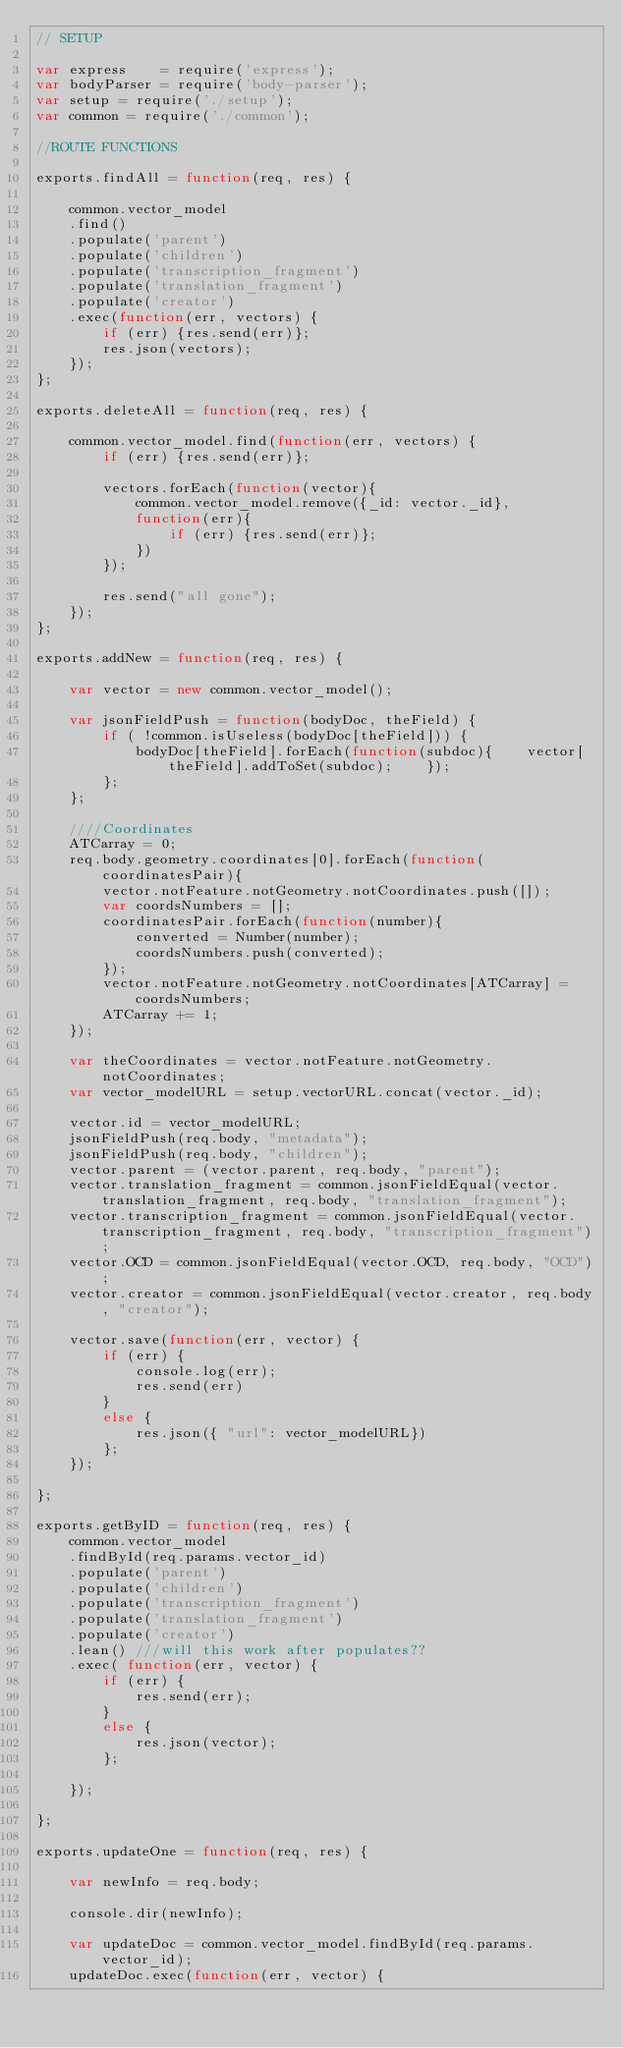Convert code to text. <code><loc_0><loc_0><loc_500><loc_500><_JavaScript_>// SETUP

var express    = require('express');
var bodyParser = require('body-parser');
var setup = require('./setup');
var common = require('./common');

//ROUTE FUNCTIONS

exports.findAll = function(req, res) {
      
    common.vector_model
    .find()
    .populate('parent')
    .populate('children')
    .populate('transcription_fragment')
    .populate('translation_fragment')
    .populate('creator')
    .exec(function(err, vectors) {
        if (err) {res.send(err)};
        res.json(vectors);
    }); 
};

exports.deleteAll = function(req, res) {
      
    common.vector_model.find(function(err, vectors) {
        if (err) {res.send(err)};

        vectors.forEach(function(vector){
            common.vector_model.remove({_id: vector._id},
            function(err){
                if (err) {res.send(err)};
            })
        });

        res.send("all gone");
    }); 
};

exports.addNew = function(req, res) {
    
    var vector = new common.vector_model(); 

    var jsonFieldPush = function(bodyDoc, theField) {
        if ( !common.isUseless(bodyDoc[theField])) {
            bodyDoc[theField].forEach(function(subdoc){    vector[theField].addToSet(subdoc);    });
        };
    };

    ////Coordinates
    ATCarray = 0;
    req.body.geometry.coordinates[0].forEach(function(coordinatesPair){
        vector.notFeature.notGeometry.notCoordinates.push([]);
        var coordsNumbers = [];
        coordinatesPair.forEach(function(number){
            converted = Number(number);
            coordsNumbers.push(converted);
        });
        vector.notFeature.notGeometry.notCoordinates[ATCarray] = coordsNumbers;
        ATCarray += 1;      
    });

    var theCoordinates = vector.notFeature.notGeometry.notCoordinates;
    var vector_modelURL = setup.vectorURL.concat(vector._id);

    vector.id = vector_modelURL;
    jsonFieldPush(req.body, "metadata");
    jsonFieldPush(req.body, "children");
    vector.parent = (vector.parent, req.body, "parent");
    vector.translation_fragment = common.jsonFieldEqual(vector.translation_fragment, req.body, "translation_fragment");
    vector.transcription_fragment = common.jsonFieldEqual(vector.transcription_fragment, req.body, "transcription_fragment");
    vector.OCD = common.jsonFieldEqual(vector.OCD, req.body, "OCD");
    vector.creator = common.jsonFieldEqual(vector.creator, req.body, "creator");

    vector.save(function(err, vector) {
        if (err) {
            console.log(err);
            res.send(err)
        }
        else {
            res.json({ "url": vector_modelURL})
        };
    });

};

exports.getByID = function(req, res) {
    common.vector_model
    .findById(req.params.vector_id)
    .populate('parent')
    .populate('children')
    .populate('transcription_fragment')
    .populate('translation_fragment')
    .populate('creator')
    .lean() ///will this work after populates??
    .exec( function(err, vector) {
        if (err) {
            res.send(err);     
        }
        else {
            res.json(vector);
        };
        
    });

};

exports.updateOne = function(req, res) {

    var newInfo = req.body;

    console.dir(newInfo);

    var updateDoc = common.vector_model.findById(req.params.vector_id); 
    updateDoc.exec(function(err, vector) {</code> 